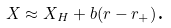<formula> <loc_0><loc_0><loc_500><loc_500>X \approx X _ { H } + b ( r - r _ { + } ) \text {.}</formula> 